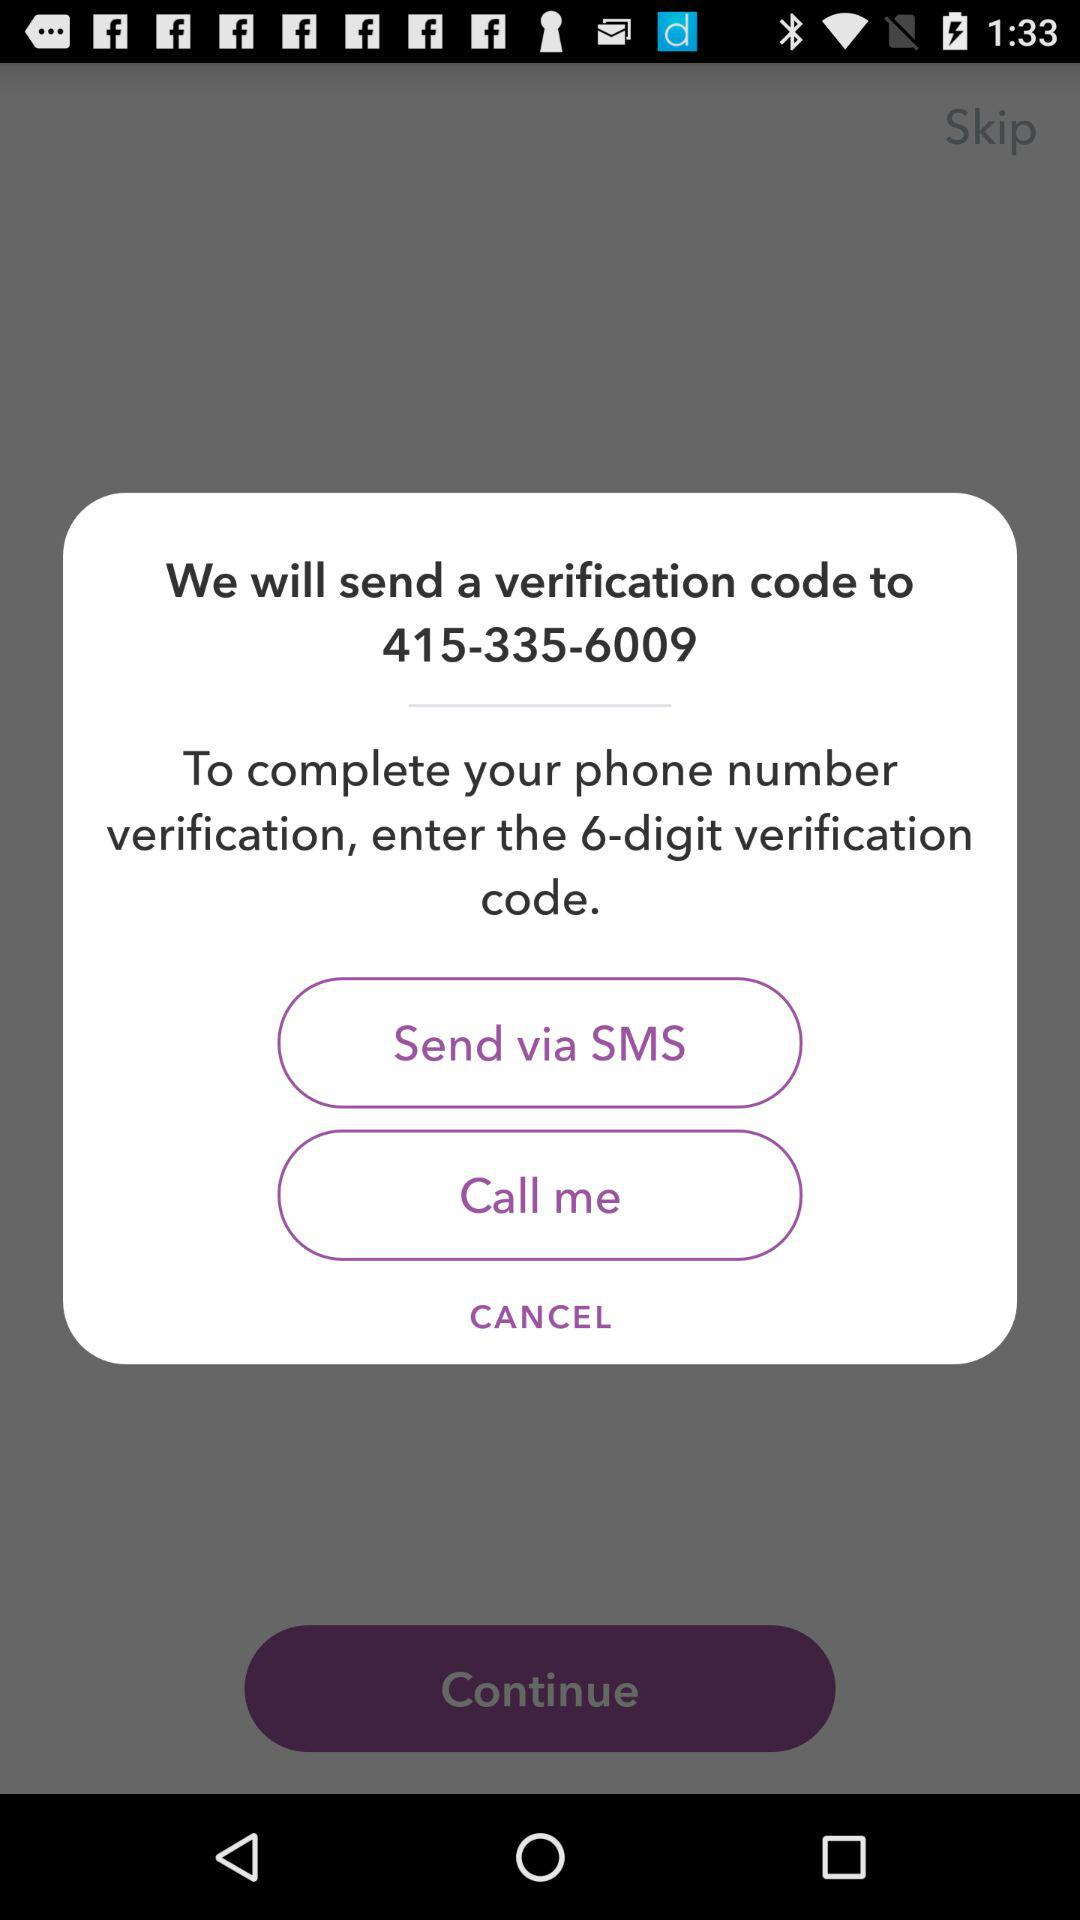How many numbers of digits do we enter to complete the verification? The number of digits is 6. 